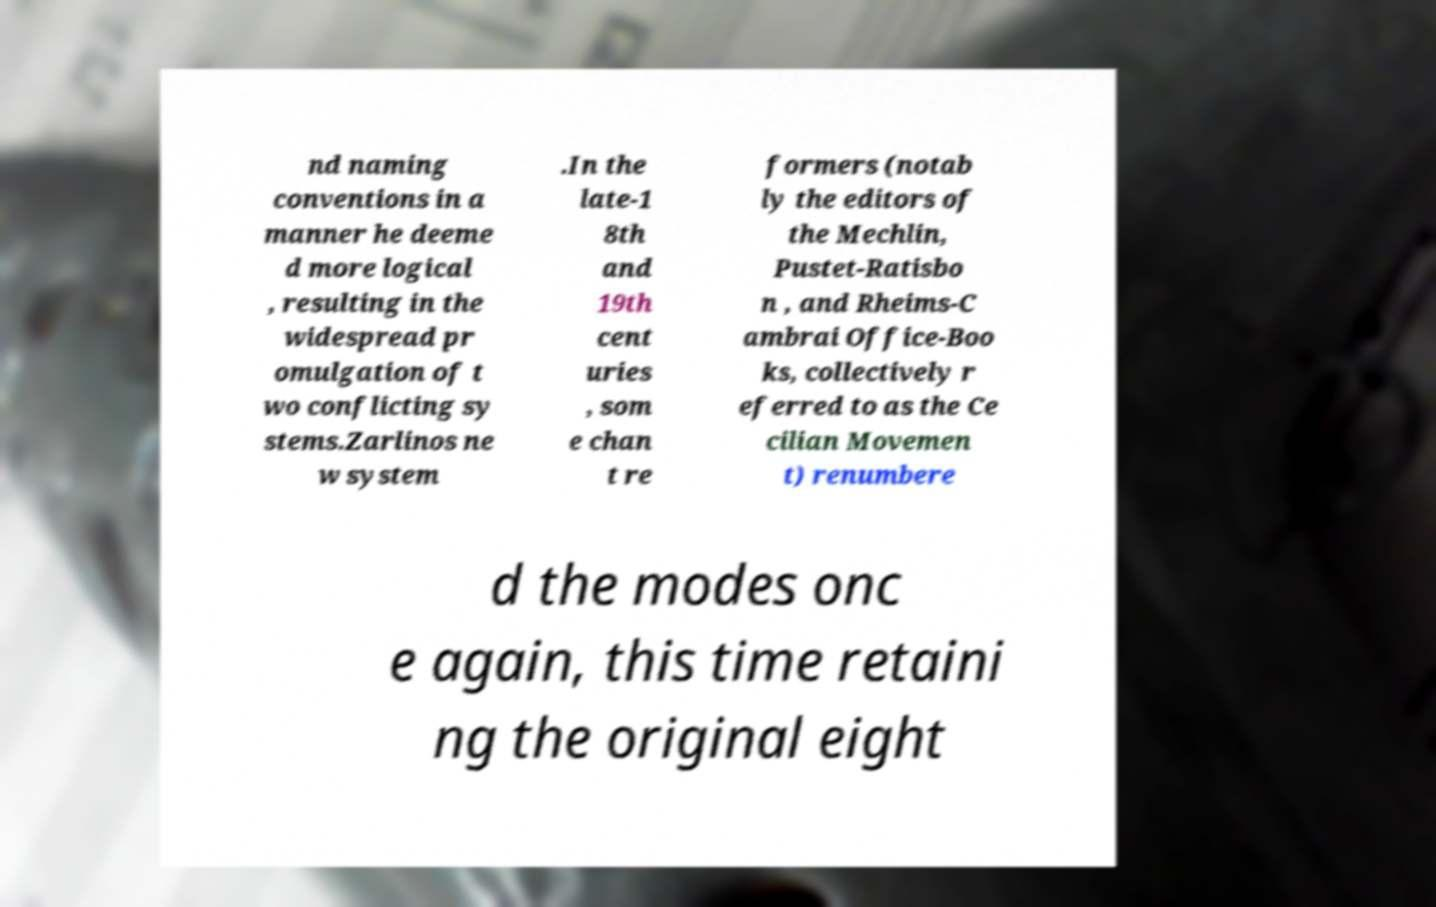I need the written content from this picture converted into text. Can you do that? nd naming conventions in a manner he deeme d more logical , resulting in the widespread pr omulgation of t wo conflicting sy stems.Zarlinos ne w system .In the late-1 8th and 19th cent uries , som e chan t re formers (notab ly the editors of the Mechlin, Pustet-Ratisbo n , and Rheims-C ambrai Office-Boo ks, collectively r eferred to as the Ce cilian Movemen t) renumbere d the modes onc e again, this time retaini ng the original eight 